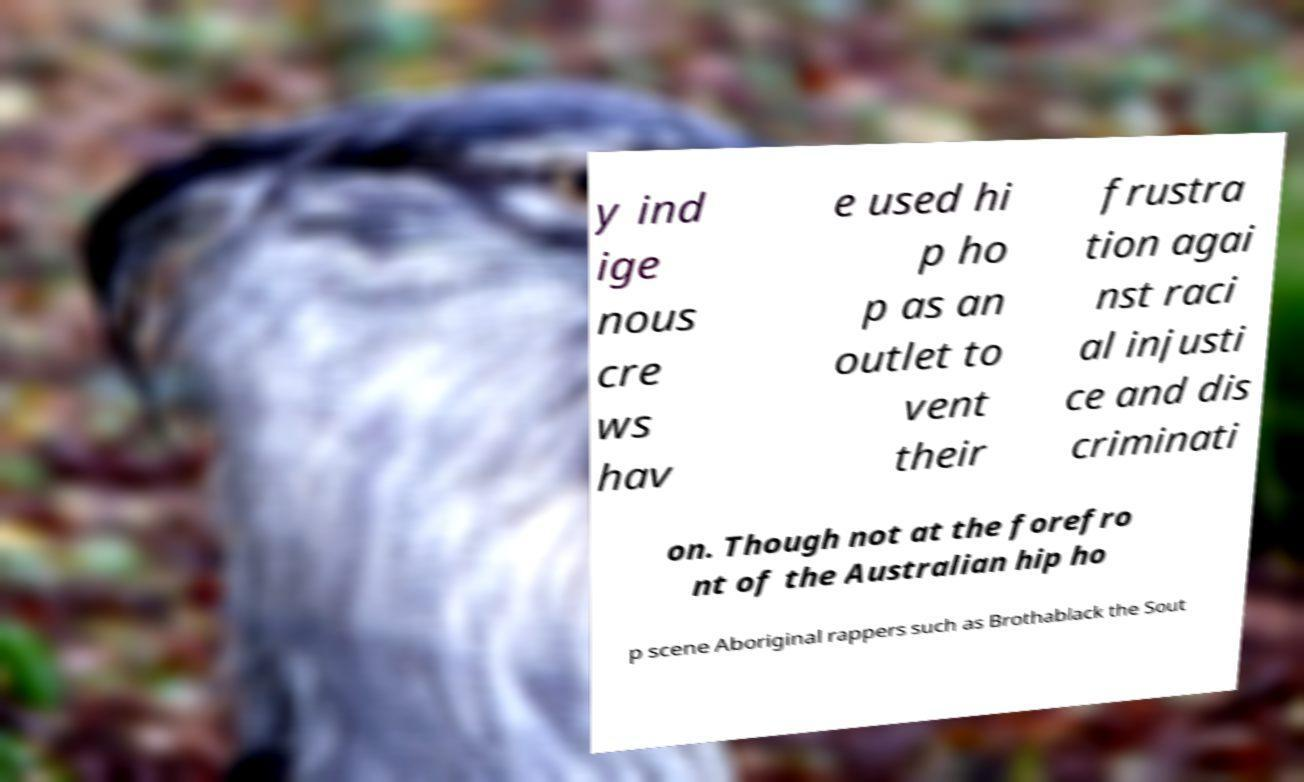Can you read and provide the text displayed in the image?This photo seems to have some interesting text. Can you extract and type it out for me? y ind ige nous cre ws hav e used hi p ho p as an outlet to vent their frustra tion agai nst raci al injusti ce and dis criminati on. Though not at the forefro nt of the Australian hip ho p scene Aboriginal rappers such as Brothablack the Sout 